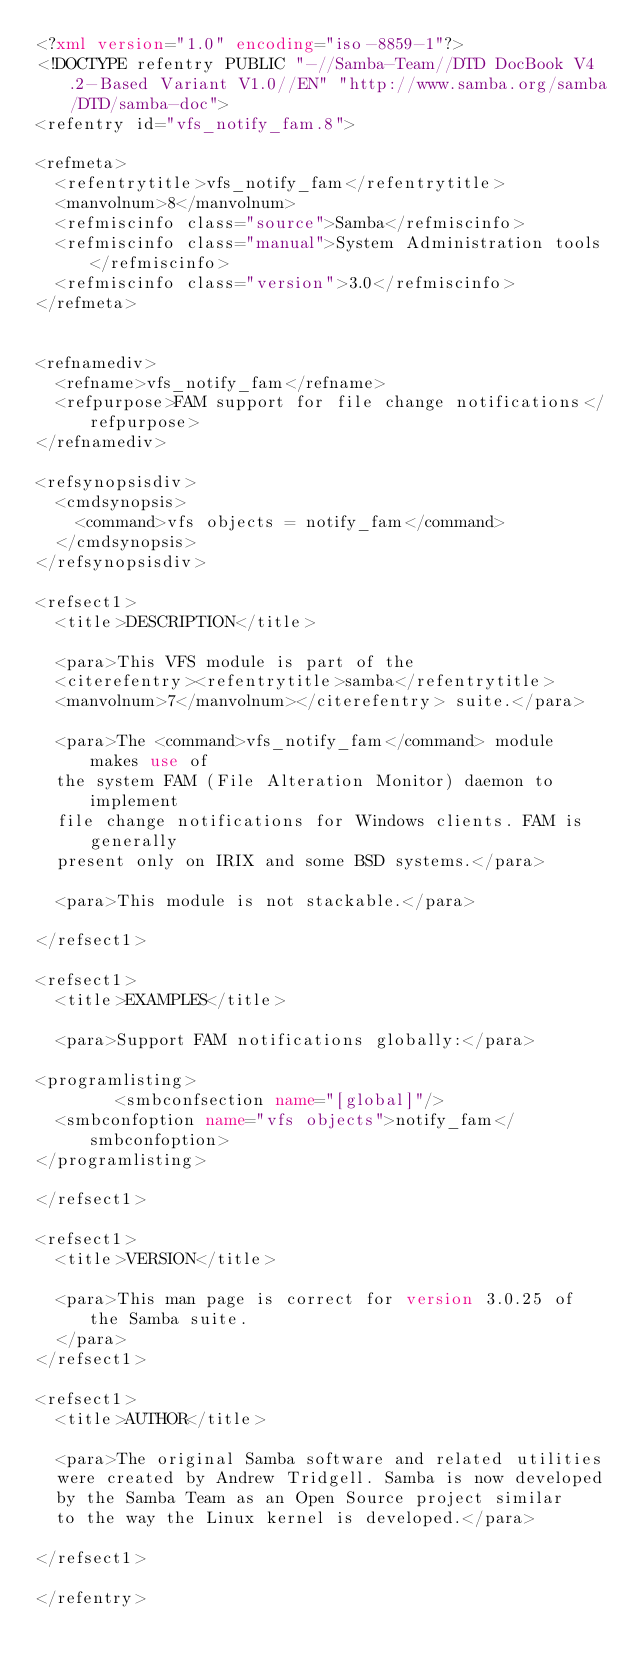<code> <loc_0><loc_0><loc_500><loc_500><_XML_><?xml version="1.0" encoding="iso-8859-1"?>
<!DOCTYPE refentry PUBLIC "-//Samba-Team//DTD DocBook V4.2-Based Variant V1.0//EN" "http://www.samba.org/samba/DTD/samba-doc">
<refentry id="vfs_notify_fam.8">

<refmeta>
	<refentrytitle>vfs_notify_fam</refentrytitle>
	<manvolnum>8</manvolnum>
	<refmiscinfo class="source">Samba</refmiscinfo>
	<refmiscinfo class="manual">System Administration tools</refmiscinfo>
	<refmiscinfo class="version">3.0</refmiscinfo>
</refmeta>


<refnamediv>
	<refname>vfs_notify_fam</refname>
	<refpurpose>FAM support for file change notifications</refpurpose>
</refnamediv>

<refsynopsisdiv>
	<cmdsynopsis>
		<command>vfs objects = notify_fam</command>
	</cmdsynopsis>
</refsynopsisdiv>

<refsect1>
	<title>DESCRIPTION</title>

	<para>This VFS module is part of the
	<citerefentry><refentrytitle>samba</refentrytitle>
	<manvolnum>7</manvolnum></citerefentry> suite.</para>

	<para>The <command>vfs_notify_fam</command> module makes use of
	the system FAM (File Alteration Monitor) daemon to implement
	file change notifications for Windows clients. FAM is generally
	present only on IRIX and some BSD systems.</para>

	<para>This module is not stackable.</para>

</refsect1>

<refsect1>
	<title>EXAMPLES</title>

	<para>Support FAM notifications globally:</para>

<programlisting>
        <smbconfsection name="[global]"/>
	<smbconfoption name="vfs objects">notify_fam</smbconfoption>
</programlisting>

</refsect1>

<refsect1>
	<title>VERSION</title>

	<para>This man page is correct for version 3.0.25 of the Samba suite.
	</para>
</refsect1>

<refsect1>
	<title>AUTHOR</title>

	<para>The original Samba software and related utilities
	were created by Andrew Tridgell. Samba is now developed
	by the Samba Team as an Open Source project similar
	to the way the Linux kernel is developed.</para>

</refsect1>

</refentry>
</code> 